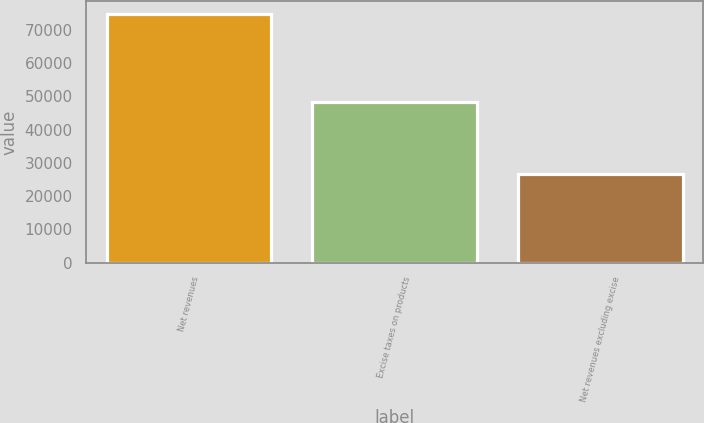<chart> <loc_0><loc_0><loc_500><loc_500><bar_chart><fcel>Net revenues<fcel>Excise taxes on products<fcel>Net revenues excluding excise<nl><fcel>74953<fcel>48268<fcel>26685<nl></chart> 